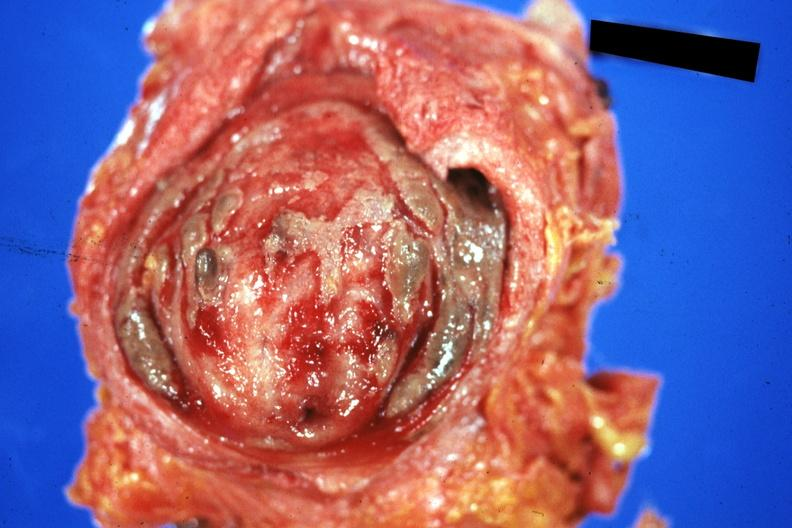s cystitis ulcerative purulent present?
Answer the question using a single word or phrase. Yes 